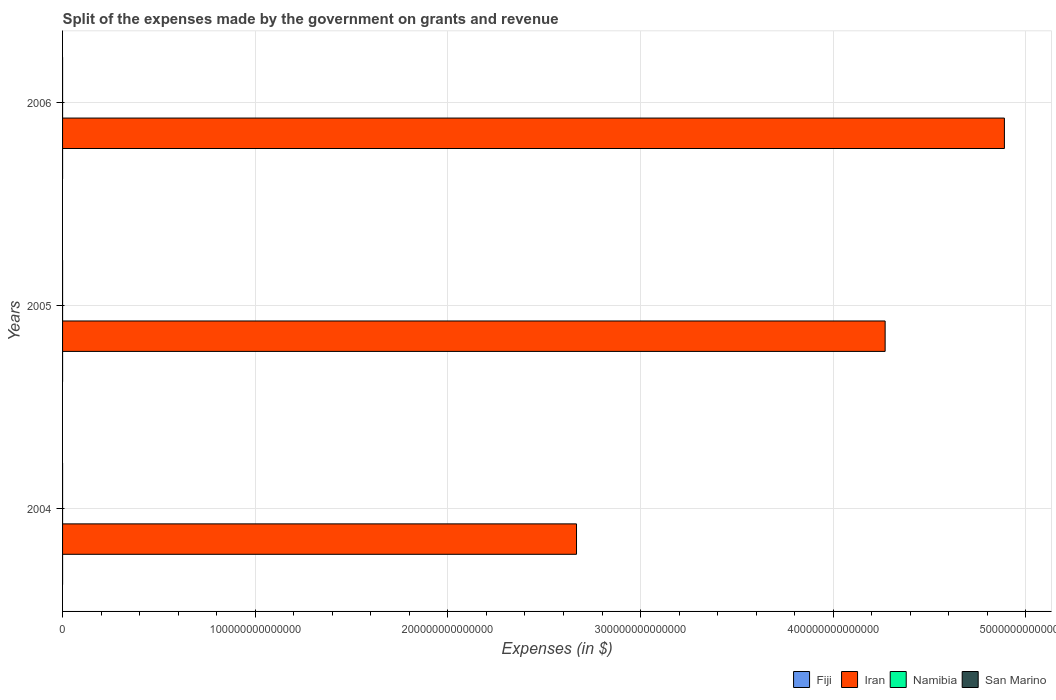How many groups of bars are there?
Offer a very short reply. 3. Are the number of bars per tick equal to the number of legend labels?
Your answer should be compact. Yes. How many bars are there on the 2nd tick from the bottom?
Your answer should be very brief. 4. What is the expenses made by the government on grants and revenue in San Marino in 2004?
Keep it short and to the point. 1.77e+08. Across all years, what is the maximum expenses made by the government on grants and revenue in Namibia?
Keep it short and to the point. 1.75e+09. Across all years, what is the minimum expenses made by the government on grants and revenue in San Marino?
Give a very brief answer. 1.52e+08. What is the total expenses made by the government on grants and revenue in Iran in the graph?
Your answer should be very brief. 1.18e+15. What is the difference between the expenses made by the government on grants and revenue in San Marino in 2005 and that in 2006?
Your response must be concise. 2.09e+06. What is the difference between the expenses made by the government on grants and revenue in Fiji in 2004 and the expenses made by the government on grants and revenue in Iran in 2005?
Offer a very short reply. -4.27e+14. What is the average expenses made by the government on grants and revenue in Namibia per year?
Keep it short and to the point. 1.25e+09. In the year 2004, what is the difference between the expenses made by the government on grants and revenue in San Marino and expenses made by the government on grants and revenue in Namibia?
Offer a very short reply. -7.20e+08. What is the ratio of the expenses made by the government on grants and revenue in Iran in 2004 to that in 2005?
Provide a short and direct response. 0.62. Is the expenses made by the government on grants and revenue in Iran in 2004 less than that in 2005?
Your answer should be very brief. Yes. What is the difference between the highest and the second highest expenses made by the government on grants and revenue in San Marino?
Offer a very short reply. 2.28e+07. What is the difference between the highest and the lowest expenses made by the government on grants and revenue in Namibia?
Provide a succinct answer. 8.49e+08. In how many years, is the expenses made by the government on grants and revenue in Namibia greater than the average expenses made by the government on grants and revenue in Namibia taken over all years?
Offer a terse response. 1. Is it the case that in every year, the sum of the expenses made by the government on grants and revenue in Iran and expenses made by the government on grants and revenue in San Marino is greater than the sum of expenses made by the government on grants and revenue in Namibia and expenses made by the government on grants and revenue in Fiji?
Give a very brief answer. Yes. What does the 2nd bar from the top in 2005 represents?
Offer a very short reply. Namibia. What does the 2nd bar from the bottom in 2005 represents?
Ensure brevity in your answer.  Iran. How many bars are there?
Your answer should be compact. 12. Are all the bars in the graph horizontal?
Keep it short and to the point. Yes. What is the difference between two consecutive major ticks on the X-axis?
Your answer should be compact. 1.00e+14. Does the graph contain any zero values?
Provide a succinct answer. No. Does the graph contain grids?
Provide a short and direct response. Yes. Where does the legend appear in the graph?
Offer a terse response. Bottom right. How are the legend labels stacked?
Offer a very short reply. Horizontal. What is the title of the graph?
Your response must be concise. Split of the expenses made by the government on grants and revenue. What is the label or title of the X-axis?
Give a very brief answer. Expenses (in $). What is the Expenses (in $) in Fiji in 2004?
Your answer should be compact. 1.27e+08. What is the Expenses (in $) in Iran in 2004?
Provide a short and direct response. 2.67e+14. What is the Expenses (in $) of Namibia in 2004?
Offer a terse response. 8.97e+08. What is the Expenses (in $) of San Marino in 2004?
Provide a short and direct response. 1.77e+08. What is the Expenses (in $) of Fiji in 2005?
Give a very brief answer. 1.38e+08. What is the Expenses (in $) of Iran in 2005?
Provide a succinct answer. 4.27e+14. What is the Expenses (in $) in Namibia in 2005?
Give a very brief answer. 1.10e+09. What is the Expenses (in $) in San Marino in 2005?
Offer a very short reply. 1.54e+08. What is the Expenses (in $) in Fiji in 2006?
Make the answer very short. 1.28e+08. What is the Expenses (in $) of Iran in 2006?
Keep it short and to the point. 4.89e+14. What is the Expenses (in $) in Namibia in 2006?
Offer a terse response. 1.75e+09. What is the Expenses (in $) in San Marino in 2006?
Make the answer very short. 1.52e+08. Across all years, what is the maximum Expenses (in $) of Fiji?
Your answer should be compact. 1.38e+08. Across all years, what is the maximum Expenses (in $) of Iran?
Provide a succinct answer. 4.89e+14. Across all years, what is the maximum Expenses (in $) in Namibia?
Your answer should be compact. 1.75e+09. Across all years, what is the maximum Expenses (in $) in San Marino?
Your response must be concise. 1.77e+08. Across all years, what is the minimum Expenses (in $) of Fiji?
Give a very brief answer. 1.27e+08. Across all years, what is the minimum Expenses (in $) in Iran?
Keep it short and to the point. 2.67e+14. Across all years, what is the minimum Expenses (in $) of Namibia?
Your answer should be very brief. 8.97e+08. Across all years, what is the minimum Expenses (in $) of San Marino?
Offer a very short reply. 1.52e+08. What is the total Expenses (in $) of Fiji in the graph?
Offer a very short reply. 3.93e+08. What is the total Expenses (in $) of Iran in the graph?
Make the answer very short. 1.18e+15. What is the total Expenses (in $) in Namibia in the graph?
Your answer should be compact. 3.74e+09. What is the total Expenses (in $) in San Marino in the graph?
Your answer should be very brief. 4.83e+08. What is the difference between the Expenses (in $) in Fiji in 2004 and that in 2005?
Ensure brevity in your answer.  -1.07e+07. What is the difference between the Expenses (in $) in Iran in 2004 and that in 2005?
Your answer should be compact. -1.60e+14. What is the difference between the Expenses (in $) of Namibia in 2004 and that in 2005?
Provide a short and direct response. -2.00e+08. What is the difference between the Expenses (in $) in San Marino in 2004 and that in 2005?
Make the answer very short. 2.28e+07. What is the difference between the Expenses (in $) in Fiji in 2004 and that in 2006?
Offer a terse response. -4.86e+05. What is the difference between the Expenses (in $) in Iran in 2004 and that in 2006?
Provide a short and direct response. -2.22e+14. What is the difference between the Expenses (in $) of Namibia in 2004 and that in 2006?
Make the answer very short. -8.49e+08. What is the difference between the Expenses (in $) in San Marino in 2004 and that in 2006?
Your response must be concise. 2.49e+07. What is the difference between the Expenses (in $) of Fiji in 2005 and that in 2006?
Your answer should be very brief. 1.02e+07. What is the difference between the Expenses (in $) of Iran in 2005 and that in 2006?
Your answer should be very brief. -6.19e+13. What is the difference between the Expenses (in $) in Namibia in 2005 and that in 2006?
Your response must be concise. -6.48e+08. What is the difference between the Expenses (in $) of San Marino in 2005 and that in 2006?
Ensure brevity in your answer.  2.09e+06. What is the difference between the Expenses (in $) of Fiji in 2004 and the Expenses (in $) of Iran in 2005?
Provide a short and direct response. -4.27e+14. What is the difference between the Expenses (in $) of Fiji in 2004 and the Expenses (in $) of Namibia in 2005?
Provide a short and direct response. -9.70e+08. What is the difference between the Expenses (in $) of Fiji in 2004 and the Expenses (in $) of San Marino in 2005?
Offer a very short reply. -2.68e+07. What is the difference between the Expenses (in $) in Iran in 2004 and the Expenses (in $) in Namibia in 2005?
Your answer should be compact. 2.67e+14. What is the difference between the Expenses (in $) in Iran in 2004 and the Expenses (in $) in San Marino in 2005?
Offer a terse response. 2.67e+14. What is the difference between the Expenses (in $) of Namibia in 2004 and the Expenses (in $) of San Marino in 2005?
Ensure brevity in your answer.  7.43e+08. What is the difference between the Expenses (in $) of Fiji in 2004 and the Expenses (in $) of Iran in 2006?
Keep it short and to the point. -4.89e+14. What is the difference between the Expenses (in $) of Fiji in 2004 and the Expenses (in $) of Namibia in 2006?
Offer a very short reply. -1.62e+09. What is the difference between the Expenses (in $) in Fiji in 2004 and the Expenses (in $) in San Marino in 2006?
Your answer should be compact. -2.47e+07. What is the difference between the Expenses (in $) of Iran in 2004 and the Expenses (in $) of Namibia in 2006?
Make the answer very short. 2.67e+14. What is the difference between the Expenses (in $) of Iran in 2004 and the Expenses (in $) of San Marino in 2006?
Your answer should be compact. 2.67e+14. What is the difference between the Expenses (in $) of Namibia in 2004 and the Expenses (in $) of San Marino in 2006?
Your response must be concise. 7.45e+08. What is the difference between the Expenses (in $) of Fiji in 2005 and the Expenses (in $) of Iran in 2006?
Offer a terse response. -4.89e+14. What is the difference between the Expenses (in $) in Fiji in 2005 and the Expenses (in $) in Namibia in 2006?
Make the answer very short. -1.61e+09. What is the difference between the Expenses (in $) in Fiji in 2005 and the Expenses (in $) in San Marino in 2006?
Make the answer very short. -1.40e+07. What is the difference between the Expenses (in $) in Iran in 2005 and the Expenses (in $) in Namibia in 2006?
Ensure brevity in your answer.  4.27e+14. What is the difference between the Expenses (in $) in Iran in 2005 and the Expenses (in $) in San Marino in 2006?
Your answer should be very brief. 4.27e+14. What is the difference between the Expenses (in $) in Namibia in 2005 and the Expenses (in $) in San Marino in 2006?
Your response must be concise. 9.46e+08. What is the average Expenses (in $) of Fiji per year?
Ensure brevity in your answer.  1.31e+08. What is the average Expenses (in $) of Iran per year?
Your answer should be compact. 3.94e+14. What is the average Expenses (in $) of Namibia per year?
Ensure brevity in your answer.  1.25e+09. What is the average Expenses (in $) in San Marino per year?
Your answer should be compact. 1.61e+08. In the year 2004, what is the difference between the Expenses (in $) of Fiji and Expenses (in $) of Iran?
Give a very brief answer. -2.67e+14. In the year 2004, what is the difference between the Expenses (in $) of Fiji and Expenses (in $) of Namibia?
Provide a short and direct response. -7.70e+08. In the year 2004, what is the difference between the Expenses (in $) of Fiji and Expenses (in $) of San Marino?
Provide a short and direct response. -4.96e+07. In the year 2004, what is the difference between the Expenses (in $) of Iran and Expenses (in $) of Namibia?
Keep it short and to the point. 2.67e+14. In the year 2004, what is the difference between the Expenses (in $) of Iran and Expenses (in $) of San Marino?
Provide a succinct answer. 2.67e+14. In the year 2004, what is the difference between the Expenses (in $) in Namibia and Expenses (in $) in San Marino?
Your answer should be very brief. 7.20e+08. In the year 2005, what is the difference between the Expenses (in $) of Fiji and Expenses (in $) of Iran?
Offer a terse response. -4.27e+14. In the year 2005, what is the difference between the Expenses (in $) of Fiji and Expenses (in $) of Namibia?
Provide a succinct answer. -9.60e+08. In the year 2005, what is the difference between the Expenses (in $) of Fiji and Expenses (in $) of San Marino?
Ensure brevity in your answer.  -1.61e+07. In the year 2005, what is the difference between the Expenses (in $) in Iran and Expenses (in $) in Namibia?
Your answer should be very brief. 4.27e+14. In the year 2005, what is the difference between the Expenses (in $) of Iran and Expenses (in $) of San Marino?
Offer a terse response. 4.27e+14. In the year 2005, what is the difference between the Expenses (in $) of Namibia and Expenses (in $) of San Marino?
Provide a succinct answer. 9.44e+08. In the year 2006, what is the difference between the Expenses (in $) in Fiji and Expenses (in $) in Iran?
Give a very brief answer. -4.89e+14. In the year 2006, what is the difference between the Expenses (in $) in Fiji and Expenses (in $) in Namibia?
Make the answer very short. -1.62e+09. In the year 2006, what is the difference between the Expenses (in $) of Fiji and Expenses (in $) of San Marino?
Your answer should be compact. -2.42e+07. In the year 2006, what is the difference between the Expenses (in $) of Iran and Expenses (in $) of Namibia?
Give a very brief answer. 4.89e+14. In the year 2006, what is the difference between the Expenses (in $) of Iran and Expenses (in $) of San Marino?
Give a very brief answer. 4.89e+14. In the year 2006, what is the difference between the Expenses (in $) of Namibia and Expenses (in $) of San Marino?
Your response must be concise. 1.59e+09. What is the ratio of the Expenses (in $) in Fiji in 2004 to that in 2005?
Your response must be concise. 0.92. What is the ratio of the Expenses (in $) in Iran in 2004 to that in 2005?
Your answer should be compact. 0.62. What is the ratio of the Expenses (in $) of Namibia in 2004 to that in 2005?
Ensure brevity in your answer.  0.82. What is the ratio of the Expenses (in $) in San Marino in 2004 to that in 2005?
Provide a succinct answer. 1.15. What is the ratio of the Expenses (in $) of Iran in 2004 to that in 2006?
Keep it short and to the point. 0.55. What is the ratio of the Expenses (in $) in Namibia in 2004 to that in 2006?
Your response must be concise. 0.51. What is the ratio of the Expenses (in $) of San Marino in 2004 to that in 2006?
Make the answer very short. 1.16. What is the ratio of the Expenses (in $) in Fiji in 2005 to that in 2006?
Offer a very short reply. 1.08. What is the ratio of the Expenses (in $) in Iran in 2005 to that in 2006?
Offer a terse response. 0.87. What is the ratio of the Expenses (in $) in Namibia in 2005 to that in 2006?
Offer a terse response. 0.63. What is the ratio of the Expenses (in $) in San Marino in 2005 to that in 2006?
Offer a very short reply. 1.01. What is the difference between the highest and the second highest Expenses (in $) in Fiji?
Make the answer very short. 1.02e+07. What is the difference between the highest and the second highest Expenses (in $) of Iran?
Keep it short and to the point. 6.19e+13. What is the difference between the highest and the second highest Expenses (in $) of Namibia?
Your response must be concise. 6.48e+08. What is the difference between the highest and the second highest Expenses (in $) of San Marino?
Keep it short and to the point. 2.28e+07. What is the difference between the highest and the lowest Expenses (in $) of Fiji?
Provide a short and direct response. 1.07e+07. What is the difference between the highest and the lowest Expenses (in $) of Iran?
Provide a succinct answer. 2.22e+14. What is the difference between the highest and the lowest Expenses (in $) in Namibia?
Make the answer very short. 8.49e+08. What is the difference between the highest and the lowest Expenses (in $) of San Marino?
Make the answer very short. 2.49e+07. 